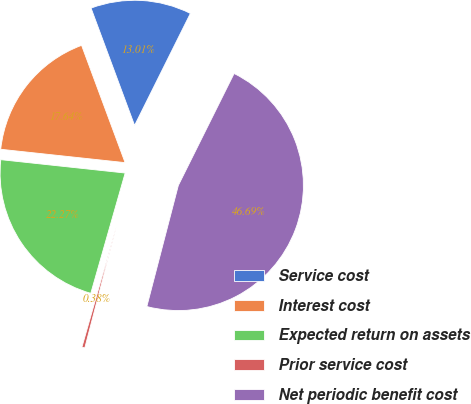<chart> <loc_0><loc_0><loc_500><loc_500><pie_chart><fcel>Service cost<fcel>Interest cost<fcel>Expected return on assets<fcel>Prior service cost<fcel>Net periodic benefit cost<nl><fcel>13.01%<fcel>17.64%<fcel>22.27%<fcel>0.38%<fcel>46.69%<nl></chart> 